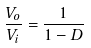Convert formula to latex. <formula><loc_0><loc_0><loc_500><loc_500>\frac { V _ { o } } { V _ { i } } = \frac { 1 } { 1 - D }</formula> 